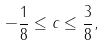Convert formula to latex. <formula><loc_0><loc_0><loc_500><loc_500>- \frac { 1 } { 8 } \leq c \leq \frac { 3 } { 8 } ,</formula> 